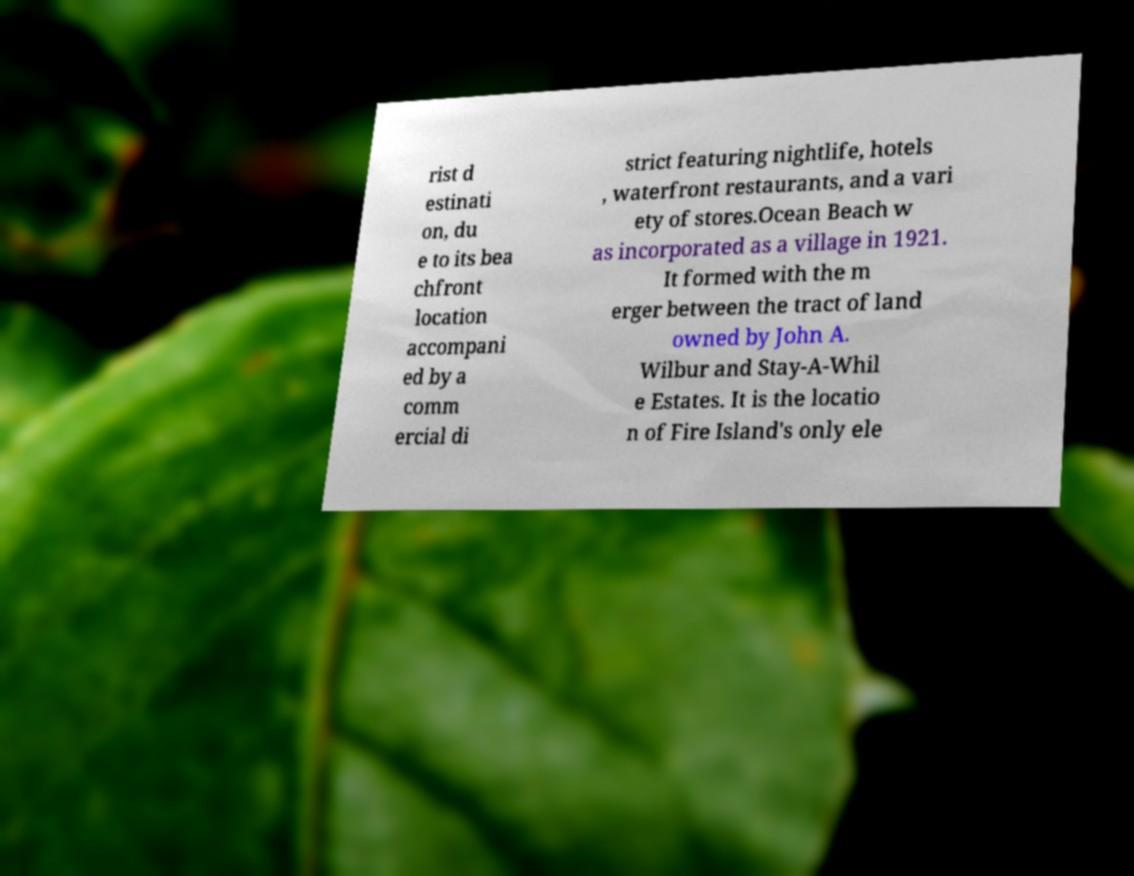Please read and relay the text visible in this image. What does it say? rist d estinati on, du e to its bea chfront location accompani ed by a comm ercial di strict featuring nightlife, hotels , waterfront restaurants, and a vari ety of stores.Ocean Beach w as incorporated as a village in 1921. It formed with the m erger between the tract of land owned by John A. Wilbur and Stay-A-Whil e Estates. It is the locatio n of Fire Island's only ele 